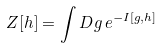<formula> <loc_0><loc_0><loc_500><loc_500>Z [ h ] = \int D g \, e ^ { - I [ g , h ] }</formula> 